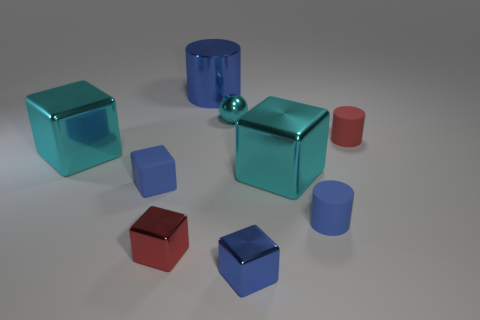Which object in the image could contain the most liquid, assuming they are hollow and have open tops? Based on the image, the large blue cylinder would likely hold the most liquid if it were hollow with an open top. Its dimensions appear to be the largest in the group of objects.  Can you tell if the light source in the scene is located more towards the left or the right? The shadows of the objects in the image tend to lean towards the right, suggesting that the light source illuminating the scene originates from the left side. 